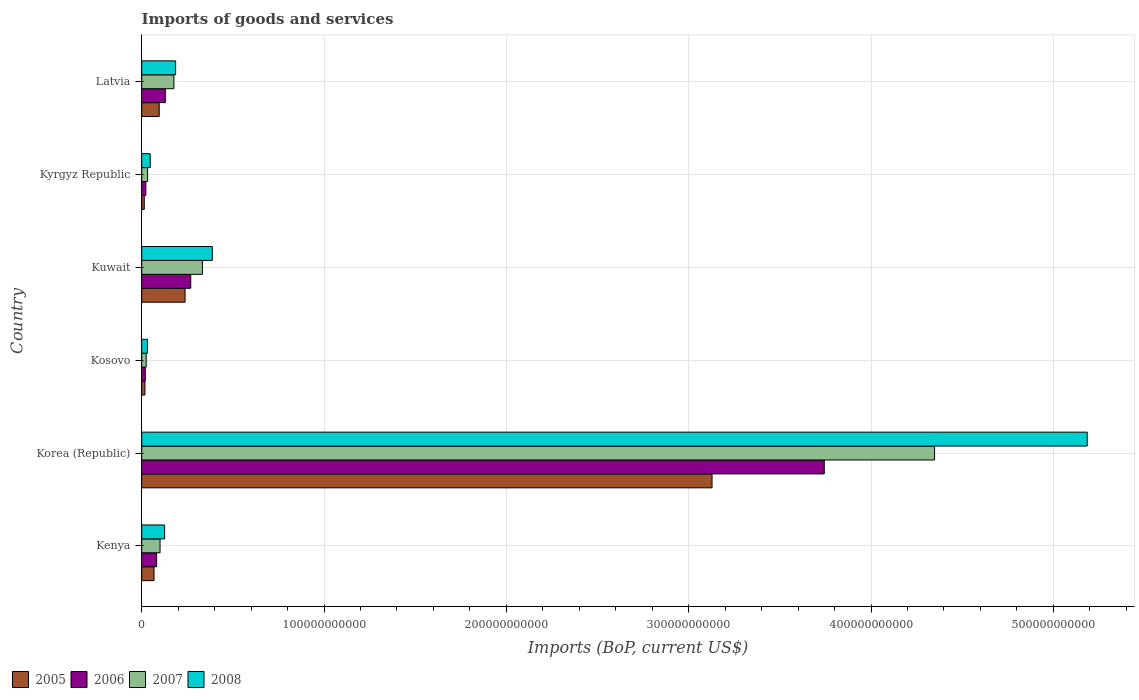Are the number of bars per tick equal to the number of legend labels?
Ensure brevity in your answer.  Yes. Are the number of bars on each tick of the Y-axis equal?
Offer a very short reply. Yes. How many bars are there on the 5th tick from the bottom?
Offer a very short reply. 4. What is the label of the 5th group of bars from the top?
Your answer should be very brief. Korea (Republic). What is the amount spent on imports in 2006 in Korea (Republic)?
Offer a terse response. 3.74e+11. Across all countries, what is the maximum amount spent on imports in 2005?
Keep it short and to the point. 3.13e+11. Across all countries, what is the minimum amount spent on imports in 2006?
Ensure brevity in your answer.  1.95e+09. In which country was the amount spent on imports in 2007 maximum?
Provide a short and direct response. Korea (Republic). In which country was the amount spent on imports in 2008 minimum?
Offer a very short reply. Kosovo. What is the total amount spent on imports in 2008 in the graph?
Give a very brief answer. 5.96e+11. What is the difference between the amount spent on imports in 2007 in Kenya and that in Kosovo?
Ensure brevity in your answer.  7.60e+09. What is the difference between the amount spent on imports in 2005 in Kuwait and the amount spent on imports in 2008 in Latvia?
Keep it short and to the point. 5.17e+09. What is the average amount spent on imports in 2005 per country?
Offer a terse response. 5.93e+1. What is the difference between the amount spent on imports in 2005 and amount spent on imports in 2006 in Latvia?
Give a very brief answer. -3.35e+09. In how many countries, is the amount spent on imports in 2005 greater than 480000000000 US$?
Keep it short and to the point. 0. What is the ratio of the amount spent on imports in 2007 in Kenya to that in Latvia?
Keep it short and to the point. 0.57. Is the amount spent on imports in 2007 in Kenya less than that in Kyrgyz Republic?
Your answer should be very brief. No. What is the difference between the highest and the second highest amount spent on imports in 2008?
Provide a short and direct response. 4.80e+11. What is the difference between the highest and the lowest amount spent on imports in 2007?
Provide a succinct answer. 4.32e+11. Is the sum of the amount spent on imports in 2008 in Kenya and Kyrgyz Republic greater than the maximum amount spent on imports in 2005 across all countries?
Ensure brevity in your answer.  No. Is it the case that in every country, the sum of the amount spent on imports in 2008 and amount spent on imports in 2006 is greater than the sum of amount spent on imports in 2005 and amount spent on imports in 2007?
Make the answer very short. No. What does the 2nd bar from the bottom in Kuwait represents?
Your answer should be compact. 2006. Is it the case that in every country, the sum of the amount spent on imports in 2008 and amount spent on imports in 2006 is greater than the amount spent on imports in 2005?
Keep it short and to the point. Yes. Are all the bars in the graph horizontal?
Make the answer very short. Yes. What is the difference between two consecutive major ticks on the X-axis?
Make the answer very short. 1.00e+11. Are the values on the major ticks of X-axis written in scientific E-notation?
Your answer should be very brief. No. Does the graph contain any zero values?
Make the answer very short. No. Where does the legend appear in the graph?
Provide a succinct answer. Bottom left. How are the legend labels stacked?
Provide a succinct answer. Horizontal. What is the title of the graph?
Your answer should be compact. Imports of goods and services. Does "2001" appear as one of the legend labels in the graph?
Your answer should be very brief. No. What is the label or title of the X-axis?
Provide a succinct answer. Imports (BoP, current US$). What is the Imports (BoP, current US$) of 2005 in Kenya?
Give a very brief answer. 6.74e+09. What is the Imports (BoP, current US$) of 2006 in Kenya?
Make the answer very short. 8.17e+09. What is the Imports (BoP, current US$) in 2007 in Kenya?
Your answer should be very brief. 1.01e+1. What is the Imports (BoP, current US$) in 2008 in Kenya?
Provide a short and direct response. 1.26e+1. What is the Imports (BoP, current US$) of 2005 in Korea (Republic)?
Ensure brevity in your answer.  3.13e+11. What is the Imports (BoP, current US$) in 2006 in Korea (Republic)?
Your answer should be very brief. 3.74e+11. What is the Imports (BoP, current US$) in 2007 in Korea (Republic)?
Your response must be concise. 4.35e+11. What is the Imports (BoP, current US$) of 2008 in Korea (Republic)?
Your answer should be compact. 5.19e+11. What is the Imports (BoP, current US$) of 2005 in Kosovo?
Offer a terse response. 1.76e+09. What is the Imports (BoP, current US$) in 2006 in Kosovo?
Keep it short and to the point. 1.95e+09. What is the Imports (BoP, current US$) in 2007 in Kosovo?
Your answer should be compact. 2.46e+09. What is the Imports (BoP, current US$) in 2008 in Kosovo?
Ensure brevity in your answer.  3.12e+09. What is the Imports (BoP, current US$) of 2005 in Kuwait?
Make the answer very short. 2.38e+1. What is the Imports (BoP, current US$) in 2006 in Kuwait?
Your answer should be very brief. 2.69e+1. What is the Imports (BoP, current US$) in 2007 in Kuwait?
Ensure brevity in your answer.  3.33e+1. What is the Imports (BoP, current US$) in 2008 in Kuwait?
Provide a succinct answer. 3.87e+1. What is the Imports (BoP, current US$) in 2005 in Kyrgyz Republic?
Offer a very short reply. 1.40e+09. What is the Imports (BoP, current US$) of 2006 in Kyrgyz Republic?
Provide a succinct answer. 2.25e+09. What is the Imports (BoP, current US$) in 2007 in Kyrgyz Republic?
Ensure brevity in your answer.  3.22e+09. What is the Imports (BoP, current US$) of 2008 in Kyrgyz Republic?
Your answer should be compact. 4.66e+09. What is the Imports (BoP, current US$) of 2005 in Latvia?
Your answer should be compact. 9.60e+09. What is the Imports (BoP, current US$) in 2006 in Latvia?
Provide a short and direct response. 1.29e+1. What is the Imports (BoP, current US$) of 2007 in Latvia?
Ensure brevity in your answer.  1.76e+1. What is the Imports (BoP, current US$) in 2008 in Latvia?
Keep it short and to the point. 1.86e+1. Across all countries, what is the maximum Imports (BoP, current US$) of 2005?
Your answer should be very brief. 3.13e+11. Across all countries, what is the maximum Imports (BoP, current US$) in 2006?
Make the answer very short. 3.74e+11. Across all countries, what is the maximum Imports (BoP, current US$) in 2007?
Your response must be concise. 4.35e+11. Across all countries, what is the maximum Imports (BoP, current US$) of 2008?
Offer a terse response. 5.19e+11. Across all countries, what is the minimum Imports (BoP, current US$) in 2005?
Make the answer very short. 1.40e+09. Across all countries, what is the minimum Imports (BoP, current US$) of 2006?
Make the answer very short. 1.95e+09. Across all countries, what is the minimum Imports (BoP, current US$) of 2007?
Provide a short and direct response. 2.46e+09. Across all countries, what is the minimum Imports (BoP, current US$) in 2008?
Provide a short and direct response. 3.12e+09. What is the total Imports (BoP, current US$) in 2005 in the graph?
Your answer should be compact. 3.56e+11. What is the total Imports (BoP, current US$) of 2006 in the graph?
Give a very brief answer. 4.27e+11. What is the total Imports (BoP, current US$) of 2007 in the graph?
Give a very brief answer. 5.02e+11. What is the total Imports (BoP, current US$) in 2008 in the graph?
Your answer should be very brief. 5.96e+11. What is the difference between the Imports (BoP, current US$) of 2005 in Kenya and that in Korea (Republic)?
Make the answer very short. -3.06e+11. What is the difference between the Imports (BoP, current US$) in 2006 in Kenya and that in Korea (Republic)?
Keep it short and to the point. -3.66e+11. What is the difference between the Imports (BoP, current US$) in 2007 in Kenya and that in Korea (Republic)?
Keep it short and to the point. -4.25e+11. What is the difference between the Imports (BoP, current US$) of 2008 in Kenya and that in Korea (Republic)?
Your response must be concise. -5.06e+11. What is the difference between the Imports (BoP, current US$) of 2005 in Kenya and that in Kosovo?
Your response must be concise. 4.97e+09. What is the difference between the Imports (BoP, current US$) in 2006 in Kenya and that in Kosovo?
Provide a short and direct response. 6.22e+09. What is the difference between the Imports (BoP, current US$) in 2007 in Kenya and that in Kosovo?
Provide a succinct answer. 7.60e+09. What is the difference between the Imports (BoP, current US$) of 2008 in Kenya and that in Kosovo?
Offer a very short reply. 9.44e+09. What is the difference between the Imports (BoP, current US$) in 2005 in Kenya and that in Kuwait?
Offer a very short reply. -1.70e+1. What is the difference between the Imports (BoP, current US$) of 2006 in Kenya and that in Kuwait?
Keep it short and to the point. -1.87e+1. What is the difference between the Imports (BoP, current US$) in 2007 in Kenya and that in Kuwait?
Ensure brevity in your answer.  -2.32e+1. What is the difference between the Imports (BoP, current US$) of 2008 in Kenya and that in Kuwait?
Offer a terse response. -2.62e+1. What is the difference between the Imports (BoP, current US$) in 2005 in Kenya and that in Kyrgyz Republic?
Your answer should be compact. 5.34e+09. What is the difference between the Imports (BoP, current US$) of 2006 in Kenya and that in Kyrgyz Republic?
Ensure brevity in your answer.  5.92e+09. What is the difference between the Imports (BoP, current US$) of 2007 in Kenya and that in Kyrgyz Republic?
Your response must be concise. 6.84e+09. What is the difference between the Imports (BoP, current US$) of 2008 in Kenya and that in Kyrgyz Republic?
Make the answer very short. 7.90e+09. What is the difference between the Imports (BoP, current US$) in 2005 in Kenya and that in Latvia?
Offer a very short reply. -2.86e+09. What is the difference between the Imports (BoP, current US$) in 2006 in Kenya and that in Latvia?
Make the answer very short. -4.77e+09. What is the difference between the Imports (BoP, current US$) in 2007 in Kenya and that in Latvia?
Provide a short and direct response. -7.59e+09. What is the difference between the Imports (BoP, current US$) in 2008 in Kenya and that in Latvia?
Your response must be concise. -6.03e+09. What is the difference between the Imports (BoP, current US$) in 2005 in Korea (Republic) and that in Kosovo?
Provide a succinct answer. 3.11e+11. What is the difference between the Imports (BoP, current US$) of 2006 in Korea (Republic) and that in Kosovo?
Provide a short and direct response. 3.72e+11. What is the difference between the Imports (BoP, current US$) in 2007 in Korea (Republic) and that in Kosovo?
Give a very brief answer. 4.32e+11. What is the difference between the Imports (BoP, current US$) of 2008 in Korea (Republic) and that in Kosovo?
Your response must be concise. 5.15e+11. What is the difference between the Imports (BoP, current US$) of 2005 in Korea (Republic) and that in Kuwait?
Offer a very short reply. 2.89e+11. What is the difference between the Imports (BoP, current US$) of 2006 in Korea (Republic) and that in Kuwait?
Offer a terse response. 3.47e+11. What is the difference between the Imports (BoP, current US$) in 2007 in Korea (Republic) and that in Kuwait?
Make the answer very short. 4.02e+11. What is the difference between the Imports (BoP, current US$) of 2008 in Korea (Republic) and that in Kuwait?
Keep it short and to the point. 4.80e+11. What is the difference between the Imports (BoP, current US$) of 2005 in Korea (Republic) and that in Kyrgyz Republic?
Offer a terse response. 3.11e+11. What is the difference between the Imports (BoP, current US$) of 2006 in Korea (Republic) and that in Kyrgyz Republic?
Your response must be concise. 3.72e+11. What is the difference between the Imports (BoP, current US$) in 2007 in Korea (Republic) and that in Kyrgyz Republic?
Keep it short and to the point. 4.32e+11. What is the difference between the Imports (BoP, current US$) of 2008 in Korea (Republic) and that in Kyrgyz Republic?
Your answer should be very brief. 5.14e+11. What is the difference between the Imports (BoP, current US$) in 2005 in Korea (Republic) and that in Latvia?
Your response must be concise. 3.03e+11. What is the difference between the Imports (BoP, current US$) of 2006 in Korea (Republic) and that in Latvia?
Ensure brevity in your answer.  3.61e+11. What is the difference between the Imports (BoP, current US$) in 2007 in Korea (Republic) and that in Latvia?
Your answer should be compact. 4.17e+11. What is the difference between the Imports (BoP, current US$) of 2008 in Korea (Republic) and that in Latvia?
Your answer should be compact. 5.00e+11. What is the difference between the Imports (BoP, current US$) in 2005 in Kosovo and that in Kuwait?
Your response must be concise. -2.20e+1. What is the difference between the Imports (BoP, current US$) in 2006 in Kosovo and that in Kuwait?
Offer a very short reply. -2.49e+1. What is the difference between the Imports (BoP, current US$) of 2007 in Kosovo and that in Kuwait?
Ensure brevity in your answer.  -3.08e+1. What is the difference between the Imports (BoP, current US$) of 2008 in Kosovo and that in Kuwait?
Offer a very short reply. -3.56e+1. What is the difference between the Imports (BoP, current US$) in 2005 in Kosovo and that in Kyrgyz Republic?
Provide a succinct answer. 3.69e+08. What is the difference between the Imports (BoP, current US$) of 2006 in Kosovo and that in Kyrgyz Republic?
Your answer should be very brief. -3.02e+08. What is the difference between the Imports (BoP, current US$) in 2007 in Kosovo and that in Kyrgyz Republic?
Offer a terse response. -7.58e+08. What is the difference between the Imports (BoP, current US$) in 2008 in Kosovo and that in Kyrgyz Republic?
Ensure brevity in your answer.  -1.54e+09. What is the difference between the Imports (BoP, current US$) of 2005 in Kosovo and that in Latvia?
Provide a short and direct response. -7.83e+09. What is the difference between the Imports (BoP, current US$) in 2006 in Kosovo and that in Latvia?
Provide a succinct answer. -1.10e+1. What is the difference between the Imports (BoP, current US$) of 2007 in Kosovo and that in Latvia?
Offer a very short reply. -1.52e+1. What is the difference between the Imports (BoP, current US$) of 2008 in Kosovo and that in Latvia?
Provide a short and direct response. -1.55e+1. What is the difference between the Imports (BoP, current US$) in 2005 in Kuwait and that in Kyrgyz Republic?
Offer a very short reply. 2.24e+1. What is the difference between the Imports (BoP, current US$) in 2006 in Kuwait and that in Kyrgyz Republic?
Your response must be concise. 2.46e+1. What is the difference between the Imports (BoP, current US$) in 2007 in Kuwait and that in Kyrgyz Republic?
Make the answer very short. 3.01e+1. What is the difference between the Imports (BoP, current US$) in 2008 in Kuwait and that in Kyrgyz Republic?
Your answer should be compact. 3.41e+1. What is the difference between the Imports (BoP, current US$) of 2005 in Kuwait and that in Latvia?
Provide a short and direct response. 1.42e+1. What is the difference between the Imports (BoP, current US$) of 2006 in Kuwait and that in Latvia?
Keep it short and to the point. 1.39e+1. What is the difference between the Imports (BoP, current US$) of 2007 in Kuwait and that in Latvia?
Give a very brief answer. 1.57e+1. What is the difference between the Imports (BoP, current US$) of 2008 in Kuwait and that in Latvia?
Your response must be concise. 2.01e+1. What is the difference between the Imports (BoP, current US$) in 2005 in Kyrgyz Republic and that in Latvia?
Your answer should be compact. -8.20e+09. What is the difference between the Imports (BoP, current US$) in 2006 in Kyrgyz Republic and that in Latvia?
Ensure brevity in your answer.  -1.07e+1. What is the difference between the Imports (BoP, current US$) of 2007 in Kyrgyz Republic and that in Latvia?
Provide a short and direct response. -1.44e+1. What is the difference between the Imports (BoP, current US$) in 2008 in Kyrgyz Republic and that in Latvia?
Provide a succinct answer. -1.39e+1. What is the difference between the Imports (BoP, current US$) in 2005 in Kenya and the Imports (BoP, current US$) in 2006 in Korea (Republic)?
Give a very brief answer. -3.68e+11. What is the difference between the Imports (BoP, current US$) in 2005 in Kenya and the Imports (BoP, current US$) in 2007 in Korea (Republic)?
Make the answer very short. -4.28e+11. What is the difference between the Imports (BoP, current US$) in 2005 in Kenya and the Imports (BoP, current US$) in 2008 in Korea (Republic)?
Ensure brevity in your answer.  -5.12e+11. What is the difference between the Imports (BoP, current US$) in 2006 in Kenya and the Imports (BoP, current US$) in 2007 in Korea (Republic)?
Your answer should be compact. -4.27e+11. What is the difference between the Imports (BoP, current US$) in 2006 in Kenya and the Imports (BoP, current US$) in 2008 in Korea (Republic)?
Keep it short and to the point. -5.10e+11. What is the difference between the Imports (BoP, current US$) in 2007 in Kenya and the Imports (BoP, current US$) in 2008 in Korea (Republic)?
Your answer should be very brief. -5.09e+11. What is the difference between the Imports (BoP, current US$) of 2005 in Kenya and the Imports (BoP, current US$) of 2006 in Kosovo?
Ensure brevity in your answer.  4.79e+09. What is the difference between the Imports (BoP, current US$) in 2005 in Kenya and the Imports (BoP, current US$) in 2007 in Kosovo?
Provide a succinct answer. 4.28e+09. What is the difference between the Imports (BoP, current US$) of 2005 in Kenya and the Imports (BoP, current US$) of 2008 in Kosovo?
Your response must be concise. 3.62e+09. What is the difference between the Imports (BoP, current US$) in 2006 in Kenya and the Imports (BoP, current US$) in 2007 in Kosovo?
Make the answer very short. 5.71e+09. What is the difference between the Imports (BoP, current US$) of 2006 in Kenya and the Imports (BoP, current US$) of 2008 in Kosovo?
Keep it short and to the point. 5.05e+09. What is the difference between the Imports (BoP, current US$) in 2007 in Kenya and the Imports (BoP, current US$) in 2008 in Kosovo?
Provide a succinct answer. 6.94e+09. What is the difference between the Imports (BoP, current US$) of 2005 in Kenya and the Imports (BoP, current US$) of 2006 in Kuwait?
Your answer should be very brief. -2.01e+1. What is the difference between the Imports (BoP, current US$) of 2005 in Kenya and the Imports (BoP, current US$) of 2007 in Kuwait?
Offer a terse response. -2.66e+1. What is the difference between the Imports (BoP, current US$) in 2005 in Kenya and the Imports (BoP, current US$) in 2008 in Kuwait?
Keep it short and to the point. -3.20e+1. What is the difference between the Imports (BoP, current US$) in 2006 in Kenya and the Imports (BoP, current US$) in 2007 in Kuwait?
Give a very brief answer. -2.51e+1. What is the difference between the Imports (BoP, current US$) of 2006 in Kenya and the Imports (BoP, current US$) of 2008 in Kuwait?
Provide a short and direct response. -3.05e+1. What is the difference between the Imports (BoP, current US$) of 2007 in Kenya and the Imports (BoP, current US$) of 2008 in Kuwait?
Offer a terse response. -2.87e+1. What is the difference between the Imports (BoP, current US$) in 2005 in Kenya and the Imports (BoP, current US$) in 2006 in Kyrgyz Republic?
Ensure brevity in your answer.  4.49e+09. What is the difference between the Imports (BoP, current US$) of 2005 in Kenya and the Imports (BoP, current US$) of 2007 in Kyrgyz Republic?
Provide a short and direct response. 3.52e+09. What is the difference between the Imports (BoP, current US$) of 2005 in Kenya and the Imports (BoP, current US$) of 2008 in Kyrgyz Republic?
Your answer should be very brief. 2.08e+09. What is the difference between the Imports (BoP, current US$) in 2006 in Kenya and the Imports (BoP, current US$) in 2007 in Kyrgyz Republic?
Make the answer very short. 4.95e+09. What is the difference between the Imports (BoP, current US$) in 2006 in Kenya and the Imports (BoP, current US$) in 2008 in Kyrgyz Republic?
Your answer should be very brief. 3.51e+09. What is the difference between the Imports (BoP, current US$) of 2007 in Kenya and the Imports (BoP, current US$) of 2008 in Kyrgyz Republic?
Ensure brevity in your answer.  5.40e+09. What is the difference between the Imports (BoP, current US$) in 2005 in Kenya and the Imports (BoP, current US$) in 2006 in Latvia?
Your answer should be very brief. -6.21e+09. What is the difference between the Imports (BoP, current US$) in 2005 in Kenya and the Imports (BoP, current US$) in 2007 in Latvia?
Offer a very short reply. -1.09e+1. What is the difference between the Imports (BoP, current US$) of 2005 in Kenya and the Imports (BoP, current US$) of 2008 in Latvia?
Give a very brief answer. -1.19e+1. What is the difference between the Imports (BoP, current US$) in 2006 in Kenya and the Imports (BoP, current US$) in 2007 in Latvia?
Provide a succinct answer. -9.48e+09. What is the difference between the Imports (BoP, current US$) in 2006 in Kenya and the Imports (BoP, current US$) in 2008 in Latvia?
Offer a very short reply. -1.04e+1. What is the difference between the Imports (BoP, current US$) of 2007 in Kenya and the Imports (BoP, current US$) of 2008 in Latvia?
Your answer should be compact. -8.54e+09. What is the difference between the Imports (BoP, current US$) in 2005 in Korea (Republic) and the Imports (BoP, current US$) in 2006 in Kosovo?
Give a very brief answer. 3.11e+11. What is the difference between the Imports (BoP, current US$) of 2005 in Korea (Republic) and the Imports (BoP, current US$) of 2007 in Kosovo?
Give a very brief answer. 3.10e+11. What is the difference between the Imports (BoP, current US$) of 2005 in Korea (Republic) and the Imports (BoP, current US$) of 2008 in Kosovo?
Ensure brevity in your answer.  3.10e+11. What is the difference between the Imports (BoP, current US$) of 2006 in Korea (Republic) and the Imports (BoP, current US$) of 2007 in Kosovo?
Offer a terse response. 3.72e+11. What is the difference between the Imports (BoP, current US$) in 2006 in Korea (Republic) and the Imports (BoP, current US$) in 2008 in Kosovo?
Provide a short and direct response. 3.71e+11. What is the difference between the Imports (BoP, current US$) in 2007 in Korea (Republic) and the Imports (BoP, current US$) in 2008 in Kosovo?
Your answer should be very brief. 4.32e+11. What is the difference between the Imports (BoP, current US$) of 2005 in Korea (Republic) and the Imports (BoP, current US$) of 2006 in Kuwait?
Ensure brevity in your answer.  2.86e+11. What is the difference between the Imports (BoP, current US$) in 2005 in Korea (Republic) and the Imports (BoP, current US$) in 2007 in Kuwait?
Your response must be concise. 2.79e+11. What is the difference between the Imports (BoP, current US$) in 2005 in Korea (Republic) and the Imports (BoP, current US$) in 2008 in Kuwait?
Provide a succinct answer. 2.74e+11. What is the difference between the Imports (BoP, current US$) in 2006 in Korea (Republic) and the Imports (BoP, current US$) in 2007 in Kuwait?
Ensure brevity in your answer.  3.41e+11. What is the difference between the Imports (BoP, current US$) in 2006 in Korea (Republic) and the Imports (BoP, current US$) in 2008 in Kuwait?
Offer a terse response. 3.36e+11. What is the difference between the Imports (BoP, current US$) of 2007 in Korea (Republic) and the Imports (BoP, current US$) of 2008 in Kuwait?
Give a very brief answer. 3.96e+11. What is the difference between the Imports (BoP, current US$) in 2005 in Korea (Republic) and the Imports (BoP, current US$) in 2006 in Kyrgyz Republic?
Offer a terse response. 3.11e+11. What is the difference between the Imports (BoP, current US$) of 2005 in Korea (Republic) and the Imports (BoP, current US$) of 2007 in Kyrgyz Republic?
Keep it short and to the point. 3.10e+11. What is the difference between the Imports (BoP, current US$) in 2005 in Korea (Republic) and the Imports (BoP, current US$) in 2008 in Kyrgyz Republic?
Ensure brevity in your answer.  3.08e+11. What is the difference between the Imports (BoP, current US$) of 2006 in Korea (Republic) and the Imports (BoP, current US$) of 2007 in Kyrgyz Republic?
Your answer should be very brief. 3.71e+11. What is the difference between the Imports (BoP, current US$) in 2006 in Korea (Republic) and the Imports (BoP, current US$) in 2008 in Kyrgyz Republic?
Give a very brief answer. 3.70e+11. What is the difference between the Imports (BoP, current US$) in 2007 in Korea (Republic) and the Imports (BoP, current US$) in 2008 in Kyrgyz Republic?
Your answer should be very brief. 4.30e+11. What is the difference between the Imports (BoP, current US$) of 2005 in Korea (Republic) and the Imports (BoP, current US$) of 2006 in Latvia?
Offer a terse response. 3.00e+11. What is the difference between the Imports (BoP, current US$) in 2005 in Korea (Republic) and the Imports (BoP, current US$) in 2007 in Latvia?
Keep it short and to the point. 2.95e+11. What is the difference between the Imports (BoP, current US$) of 2005 in Korea (Republic) and the Imports (BoP, current US$) of 2008 in Latvia?
Make the answer very short. 2.94e+11. What is the difference between the Imports (BoP, current US$) in 2006 in Korea (Republic) and the Imports (BoP, current US$) in 2007 in Latvia?
Your answer should be very brief. 3.57e+11. What is the difference between the Imports (BoP, current US$) in 2006 in Korea (Republic) and the Imports (BoP, current US$) in 2008 in Latvia?
Ensure brevity in your answer.  3.56e+11. What is the difference between the Imports (BoP, current US$) in 2007 in Korea (Republic) and the Imports (BoP, current US$) in 2008 in Latvia?
Make the answer very short. 4.16e+11. What is the difference between the Imports (BoP, current US$) of 2005 in Kosovo and the Imports (BoP, current US$) of 2006 in Kuwait?
Ensure brevity in your answer.  -2.51e+1. What is the difference between the Imports (BoP, current US$) of 2005 in Kosovo and the Imports (BoP, current US$) of 2007 in Kuwait?
Ensure brevity in your answer.  -3.15e+1. What is the difference between the Imports (BoP, current US$) of 2005 in Kosovo and the Imports (BoP, current US$) of 2008 in Kuwait?
Give a very brief answer. -3.70e+1. What is the difference between the Imports (BoP, current US$) in 2006 in Kosovo and the Imports (BoP, current US$) in 2007 in Kuwait?
Ensure brevity in your answer.  -3.14e+1. What is the difference between the Imports (BoP, current US$) of 2006 in Kosovo and the Imports (BoP, current US$) of 2008 in Kuwait?
Your answer should be very brief. -3.68e+1. What is the difference between the Imports (BoP, current US$) in 2007 in Kosovo and the Imports (BoP, current US$) in 2008 in Kuwait?
Provide a short and direct response. -3.63e+1. What is the difference between the Imports (BoP, current US$) of 2005 in Kosovo and the Imports (BoP, current US$) of 2006 in Kyrgyz Republic?
Keep it short and to the point. -4.88e+08. What is the difference between the Imports (BoP, current US$) of 2005 in Kosovo and the Imports (BoP, current US$) of 2007 in Kyrgyz Republic?
Ensure brevity in your answer.  -1.45e+09. What is the difference between the Imports (BoP, current US$) in 2005 in Kosovo and the Imports (BoP, current US$) in 2008 in Kyrgyz Republic?
Your answer should be compact. -2.90e+09. What is the difference between the Imports (BoP, current US$) in 2006 in Kosovo and the Imports (BoP, current US$) in 2007 in Kyrgyz Republic?
Your response must be concise. -1.27e+09. What is the difference between the Imports (BoP, current US$) in 2006 in Kosovo and the Imports (BoP, current US$) in 2008 in Kyrgyz Republic?
Give a very brief answer. -2.71e+09. What is the difference between the Imports (BoP, current US$) of 2007 in Kosovo and the Imports (BoP, current US$) of 2008 in Kyrgyz Republic?
Your answer should be compact. -2.20e+09. What is the difference between the Imports (BoP, current US$) in 2005 in Kosovo and the Imports (BoP, current US$) in 2006 in Latvia?
Your answer should be very brief. -1.12e+1. What is the difference between the Imports (BoP, current US$) of 2005 in Kosovo and the Imports (BoP, current US$) of 2007 in Latvia?
Offer a terse response. -1.59e+1. What is the difference between the Imports (BoP, current US$) of 2005 in Kosovo and the Imports (BoP, current US$) of 2008 in Latvia?
Ensure brevity in your answer.  -1.68e+1. What is the difference between the Imports (BoP, current US$) in 2006 in Kosovo and the Imports (BoP, current US$) in 2007 in Latvia?
Your answer should be very brief. -1.57e+1. What is the difference between the Imports (BoP, current US$) in 2006 in Kosovo and the Imports (BoP, current US$) in 2008 in Latvia?
Provide a short and direct response. -1.66e+1. What is the difference between the Imports (BoP, current US$) in 2007 in Kosovo and the Imports (BoP, current US$) in 2008 in Latvia?
Offer a very short reply. -1.61e+1. What is the difference between the Imports (BoP, current US$) in 2005 in Kuwait and the Imports (BoP, current US$) in 2006 in Kyrgyz Republic?
Provide a succinct answer. 2.15e+1. What is the difference between the Imports (BoP, current US$) in 2005 in Kuwait and the Imports (BoP, current US$) in 2007 in Kyrgyz Republic?
Provide a short and direct response. 2.06e+1. What is the difference between the Imports (BoP, current US$) of 2005 in Kuwait and the Imports (BoP, current US$) of 2008 in Kyrgyz Republic?
Your response must be concise. 1.91e+1. What is the difference between the Imports (BoP, current US$) in 2006 in Kuwait and the Imports (BoP, current US$) in 2007 in Kyrgyz Republic?
Your response must be concise. 2.37e+1. What is the difference between the Imports (BoP, current US$) in 2006 in Kuwait and the Imports (BoP, current US$) in 2008 in Kyrgyz Republic?
Offer a very short reply. 2.22e+1. What is the difference between the Imports (BoP, current US$) in 2007 in Kuwait and the Imports (BoP, current US$) in 2008 in Kyrgyz Republic?
Ensure brevity in your answer.  2.86e+1. What is the difference between the Imports (BoP, current US$) of 2005 in Kuwait and the Imports (BoP, current US$) of 2006 in Latvia?
Offer a terse response. 1.08e+1. What is the difference between the Imports (BoP, current US$) of 2005 in Kuwait and the Imports (BoP, current US$) of 2007 in Latvia?
Give a very brief answer. 6.12e+09. What is the difference between the Imports (BoP, current US$) in 2005 in Kuwait and the Imports (BoP, current US$) in 2008 in Latvia?
Ensure brevity in your answer.  5.17e+09. What is the difference between the Imports (BoP, current US$) of 2006 in Kuwait and the Imports (BoP, current US$) of 2007 in Latvia?
Keep it short and to the point. 9.23e+09. What is the difference between the Imports (BoP, current US$) of 2006 in Kuwait and the Imports (BoP, current US$) of 2008 in Latvia?
Your answer should be very brief. 8.28e+09. What is the difference between the Imports (BoP, current US$) in 2007 in Kuwait and the Imports (BoP, current US$) in 2008 in Latvia?
Your response must be concise. 1.47e+1. What is the difference between the Imports (BoP, current US$) in 2005 in Kyrgyz Republic and the Imports (BoP, current US$) in 2006 in Latvia?
Make the answer very short. -1.15e+1. What is the difference between the Imports (BoP, current US$) in 2005 in Kyrgyz Republic and the Imports (BoP, current US$) in 2007 in Latvia?
Give a very brief answer. -1.63e+1. What is the difference between the Imports (BoP, current US$) in 2005 in Kyrgyz Republic and the Imports (BoP, current US$) in 2008 in Latvia?
Give a very brief answer. -1.72e+1. What is the difference between the Imports (BoP, current US$) of 2006 in Kyrgyz Republic and the Imports (BoP, current US$) of 2007 in Latvia?
Keep it short and to the point. -1.54e+1. What is the difference between the Imports (BoP, current US$) of 2006 in Kyrgyz Republic and the Imports (BoP, current US$) of 2008 in Latvia?
Give a very brief answer. -1.63e+1. What is the difference between the Imports (BoP, current US$) of 2007 in Kyrgyz Republic and the Imports (BoP, current US$) of 2008 in Latvia?
Provide a succinct answer. -1.54e+1. What is the average Imports (BoP, current US$) of 2005 per country?
Ensure brevity in your answer.  5.93e+1. What is the average Imports (BoP, current US$) of 2006 per country?
Provide a succinct answer. 7.11e+1. What is the average Imports (BoP, current US$) in 2007 per country?
Make the answer very short. 8.36e+1. What is the average Imports (BoP, current US$) in 2008 per country?
Offer a terse response. 9.94e+1. What is the difference between the Imports (BoP, current US$) of 2005 and Imports (BoP, current US$) of 2006 in Kenya?
Give a very brief answer. -1.43e+09. What is the difference between the Imports (BoP, current US$) in 2005 and Imports (BoP, current US$) in 2007 in Kenya?
Offer a very short reply. -3.32e+09. What is the difference between the Imports (BoP, current US$) of 2005 and Imports (BoP, current US$) of 2008 in Kenya?
Make the answer very short. -5.82e+09. What is the difference between the Imports (BoP, current US$) in 2006 and Imports (BoP, current US$) in 2007 in Kenya?
Your answer should be very brief. -1.89e+09. What is the difference between the Imports (BoP, current US$) of 2006 and Imports (BoP, current US$) of 2008 in Kenya?
Keep it short and to the point. -4.39e+09. What is the difference between the Imports (BoP, current US$) of 2007 and Imports (BoP, current US$) of 2008 in Kenya?
Provide a short and direct response. -2.50e+09. What is the difference between the Imports (BoP, current US$) in 2005 and Imports (BoP, current US$) in 2006 in Korea (Republic)?
Make the answer very short. -6.16e+1. What is the difference between the Imports (BoP, current US$) of 2005 and Imports (BoP, current US$) of 2007 in Korea (Republic)?
Give a very brief answer. -1.22e+11. What is the difference between the Imports (BoP, current US$) in 2005 and Imports (BoP, current US$) in 2008 in Korea (Republic)?
Your response must be concise. -2.06e+11. What is the difference between the Imports (BoP, current US$) in 2006 and Imports (BoP, current US$) in 2007 in Korea (Republic)?
Your answer should be compact. -6.05e+1. What is the difference between the Imports (BoP, current US$) of 2006 and Imports (BoP, current US$) of 2008 in Korea (Republic)?
Offer a very short reply. -1.44e+11. What is the difference between the Imports (BoP, current US$) of 2007 and Imports (BoP, current US$) of 2008 in Korea (Republic)?
Offer a terse response. -8.37e+1. What is the difference between the Imports (BoP, current US$) in 2005 and Imports (BoP, current US$) in 2006 in Kosovo?
Give a very brief answer. -1.86e+08. What is the difference between the Imports (BoP, current US$) of 2005 and Imports (BoP, current US$) of 2007 in Kosovo?
Your response must be concise. -6.96e+08. What is the difference between the Imports (BoP, current US$) of 2005 and Imports (BoP, current US$) of 2008 in Kosovo?
Give a very brief answer. -1.36e+09. What is the difference between the Imports (BoP, current US$) in 2006 and Imports (BoP, current US$) in 2007 in Kosovo?
Give a very brief answer. -5.10e+08. What is the difference between the Imports (BoP, current US$) in 2006 and Imports (BoP, current US$) in 2008 in Kosovo?
Your answer should be very brief. -1.17e+09. What is the difference between the Imports (BoP, current US$) of 2007 and Imports (BoP, current US$) of 2008 in Kosovo?
Make the answer very short. -6.61e+08. What is the difference between the Imports (BoP, current US$) in 2005 and Imports (BoP, current US$) in 2006 in Kuwait?
Your response must be concise. -3.11e+09. What is the difference between the Imports (BoP, current US$) of 2005 and Imports (BoP, current US$) of 2007 in Kuwait?
Your response must be concise. -9.54e+09. What is the difference between the Imports (BoP, current US$) of 2005 and Imports (BoP, current US$) of 2008 in Kuwait?
Keep it short and to the point. -1.49e+1. What is the difference between the Imports (BoP, current US$) in 2006 and Imports (BoP, current US$) in 2007 in Kuwait?
Keep it short and to the point. -6.43e+09. What is the difference between the Imports (BoP, current US$) of 2006 and Imports (BoP, current US$) of 2008 in Kuwait?
Ensure brevity in your answer.  -1.18e+1. What is the difference between the Imports (BoP, current US$) of 2007 and Imports (BoP, current US$) of 2008 in Kuwait?
Make the answer very short. -5.41e+09. What is the difference between the Imports (BoP, current US$) in 2005 and Imports (BoP, current US$) in 2006 in Kyrgyz Republic?
Ensure brevity in your answer.  -8.56e+08. What is the difference between the Imports (BoP, current US$) of 2005 and Imports (BoP, current US$) of 2007 in Kyrgyz Republic?
Offer a very short reply. -1.82e+09. What is the difference between the Imports (BoP, current US$) of 2005 and Imports (BoP, current US$) of 2008 in Kyrgyz Republic?
Offer a very short reply. -3.27e+09. What is the difference between the Imports (BoP, current US$) of 2006 and Imports (BoP, current US$) of 2007 in Kyrgyz Republic?
Provide a short and direct response. -9.66e+08. What is the difference between the Imports (BoP, current US$) of 2006 and Imports (BoP, current US$) of 2008 in Kyrgyz Republic?
Offer a terse response. -2.41e+09. What is the difference between the Imports (BoP, current US$) in 2007 and Imports (BoP, current US$) in 2008 in Kyrgyz Republic?
Offer a terse response. -1.45e+09. What is the difference between the Imports (BoP, current US$) in 2005 and Imports (BoP, current US$) in 2006 in Latvia?
Offer a very short reply. -3.35e+09. What is the difference between the Imports (BoP, current US$) of 2005 and Imports (BoP, current US$) of 2007 in Latvia?
Ensure brevity in your answer.  -8.05e+09. What is the difference between the Imports (BoP, current US$) in 2005 and Imports (BoP, current US$) in 2008 in Latvia?
Your answer should be very brief. -9.00e+09. What is the difference between the Imports (BoP, current US$) in 2006 and Imports (BoP, current US$) in 2007 in Latvia?
Ensure brevity in your answer.  -4.71e+09. What is the difference between the Imports (BoP, current US$) in 2006 and Imports (BoP, current US$) in 2008 in Latvia?
Offer a terse response. -5.65e+09. What is the difference between the Imports (BoP, current US$) in 2007 and Imports (BoP, current US$) in 2008 in Latvia?
Offer a very short reply. -9.45e+08. What is the ratio of the Imports (BoP, current US$) in 2005 in Kenya to that in Korea (Republic)?
Your answer should be very brief. 0.02. What is the ratio of the Imports (BoP, current US$) of 2006 in Kenya to that in Korea (Republic)?
Provide a short and direct response. 0.02. What is the ratio of the Imports (BoP, current US$) in 2007 in Kenya to that in Korea (Republic)?
Your answer should be very brief. 0.02. What is the ratio of the Imports (BoP, current US$) in 2008 in Kenya to that in Korea (Republic)?
Provide a short and direct response. 0.02. What is the ratio of the Imports (BoP, current US$) in 2005 in Kenya to that in Kosovo?
Make the answer very short. 3.82. What is the ratio of the Imports (BoP, current US$) of 2006 in Kenya to that in Kosovo?
Your answer should be very brief. 4.19. What is the ratio of the Imports (BoP, current US$) of 2007 in Kenya to that in Kosovo?
Keep it short and to the point. 4.09. What is the ratio of the Imports (BoP, current US$) of 2008 in Kenya to that in Kosovo?
Keep it short and to the point. 4.02. What is the ratio of the Imports (BoP, current US$) of 2005 in Kenya to that in Kuwait?
Provide a succinct answer. 0.28. What is the ratio of the Imports (BoP, current US$) of 2006 in Kenya to that in Kuwait?
Your response must be concise. 0.3. What is the ratio of the Imports (BoP, current US$) in 2007 in Kenya to that in Kuwait?
Provide a succinct answer. 0.3. What is the ratio of the Imports (BoP, current US$) in 2008 in Kenya to that in Kuwait?
Make the answer very short. 0.32. What is the ratio of the Imports (BoP, current US$) of 2005 in Kenya to that in Kyrgyz Republic?
Provide a short and direct response. 4.83. What is the ratio of the Imports (BoP, current US$) in 2006 in Kenya to that in Kyrgyz Republic?
Provide a succinct answer. 3.63. What is the ratio of the Imports (BoP, current US$) in 2007 in Kenya to that in Kyrgyz Republic?
Your answer should be compact. 3.13. What is the ratio of the Imports (BoP, current US$) in 2008 in Kenya to that in Kyrgyz Republic?
Offer a terse response. 2.69. What is the ratio of the Imports (BoP, current US$) in 2005 in Kenya to that in Latvia?
Keep it short and to the point. 0.7. What is the ratio of the Imports (BoP, current US$) of 2006 in Kenya to that in Latvia?
Offer a very short reply. 0.63. What is the ratio of the Imports (BoP, current US$) of 2007 in Kenya to that in Latvia?
Offer a terse response. 0.57. What is the ratio of the Imports (BoP, current US$) of 2008 in Kenya to that in Latvia?
Ensure brevity in your answer.  0.68. What is the ratio of the Imports (BoP, current US$) in 2005 in Korea (Republic) to that in Kosovo?
Keep it short and to the point. 177.28. What is the ratio of the Imports (BoP, current US$) in 2006 in Korea (Republic) to that in Kosovo?
Your response must be concise. 191.97. What is the ratio of the Imports (BoP, current US$) in 2007 in Korea (Republic) to that in Kosovo?
Ensure brevity in your answer.  176.75. What is the ratio of the Imports (BoP, current US$) in 2008 in Korea (Republic) to that in Kosovo?
Ensure brevity in your answer.  166.17. What is the ratio of the Imports (BoP, current US$) in 2005 in Korea (Republic) to that in Kuwait?
Ensure brevity in your answer.  13.16. What is the ratio of the Imports (BoP, current US$) of 2006 in Korea (Republic) to that in Kuwait?
Make the answer very short. 13.93. What is the ratio of the Imports (BoP, current US$) of 2007 in Korea (Republic) to that in Kuwait?
Give a very brief answer. 13.06. What is the ratio of the Imports (BoP, current US$) in 2008 in Korea (Republic) to that in Kuwait?
Offer a terse response. 13.39. What is the ratio of the Imports (BoP, current US$) of 2005 in Korea (Republic) to that in Kyrgyz Republic?
Ensure brevity in your answer.  224.1. What is the ratio of the Imports (BoP, current US$) of 2006 in Korea (Republic) to that in Kyrgyz Republic?
Your response must be concise. 166.22. What is the ratio of the Imports (BoP, current US$) of 2007 in Korea (Republic) to that in Kyrgyz Republic?
Make the answer very short. 135.13. What is the ratio of the Imports (BoP, current US$) in 2008 in Korea (Republic) to that in Kyrgyz Republic?
Provide a short and direct response. 111.2. What is the ratio of the Imports (BoP, current US$) in 2005 in Korea (Republic) to that in Latvia?
Offer a very short reply. 32.59. What is the ratio of the Imports (BoP, current US$) in 2006 in Korea (Republic) to that in Latvia?
Your answer should be very brief. 28.92. What is the ratio of the Imports (BoP, current US$) of 2007 in Korea (Republic) to that in Latvia?
Offer a terse response. 24.64. What is the ratio of the Imports (BoP, current US$) in 2008 in Korea (Republic) to that in Latvia?
Offer a very short reply. 27.89. What is the ratio of the Imports (BoP, current US$) in 2005 in Kosovo to that in Kuwait?
Give a very brief answer. 0.07. What is the ratio of the Imports (BoP, current US$) in 2006 in Kosovo to that in Kuwait?
Offer a terse response. 0.07. What is the ratio of the Imports (BoP, current US$) of 2007 in Kosovo to that in Kuwait?
Provide a succinct answer. 0.07. What is the ratio of the Imports (BoP, current US$) of 2008 in Kosovo to that in Kuwait?
Your answer should be compact. 0.08. What is the ratio of the Imports (BoP, current US$) of 2005 in Kosovo to that in Kyrgyz Republic?
Ensure brevity in your answer.  1.26. What is the ratio of the Imports (BoP, current US$) of 2006 in Kosovo to that in Kyrgyz Republic?
Keep it short and to the point. 0.87. What is the ratio of the Imports (BoP, current US$) in 2007 in Kosovo to that in Kyrgyz Republic?
Your answer should be compact. 0.76. What is the ratio of the Imports (BoP, current US$) in 2008 in Kosovo to that in Kyrgyz Republic?
Provide a succinct answer. 0.67. What is the ratio of the Imports (BoP, current US$) of 2005 in Kosovo to that in Latvia?
Offer a very short reply. 0.18. What is the ratio of the Imports (BoP, current US$) in 2006 in Kosovo to that in Latvia?
Provide a short and direct response. 0.15. What is the ratio of the Imports (BoP, current US$) of 2007 in Kosovo to that in Latvia?
Keep it short and to the point. 0.14. What is the ratio of the Imports (BoP, current US$) in 2008 in Kosovo to that in Latvia?
Your answer should be compact. 0.17. What is the ratio of the Imports (BoP, current US$) in 2005 in Kuwait to that in Kyrgyz Republic?
Offer a very short reply. 17.03. What is the ratio of the Imports (BoP, current US$) in 2006 in Kuwait to that in Kyrgyz Republic?
Make the answer very short. 11.93. What is the ratio of the Imports (BoP, current US$) in 2007 in Kuwait to that in Kyrgyz Republic?
Offer a terse response. 10.35. What is the ratio of the Imports (BoP, current US$) in 2008 in Kuwait to that in Kyrgyz Republic?
Your answer should be very brief. 8.3. What is the ratio of the Imports (BoP, current US$) of 2005 in Kuwait to that in Latvia?
Make the answer very short. 2.48. What is the ratio of the Imports (BoP, current US$) in 2006 in Kuwait to that in Latvia?
Give a very brief answer. 2.08. What is the ratio of the Imports (BoP, current US$) of 2007 in Kuwait to that in Latvia?
Make the answer very short. 1.89. What is the ratio of the Imports (BoP, current US$) of 2008 in Kuwait to that in Latvia?
Give a very brief answer. 2.08. What is the ratio of the Imports (BoP, current US$) of 2005 in Kyrgyz Republic to that in Latvia?
Make the answer very short. 0.15. What is the ratio of the Imports (BoP, current US$) in 2006 in Kyrgyz Republic to that in Latvia?
Your answer should be very brief. 0.17. What is the ratio of the Imports (BoP, current US$) of 2007 in Kyrgyz Republic to that in Latvia?
Offer a terse response. 0.18. What is the ratio of the Imports (BoP, current US$) in 2008 in Kyrgyz Republic to that in Latvia?
Ensure brevity in your answer.  0.25. What is the difference between the highest and the second highest Imports (BoP, current US$) in 2005?
Your answer should be compact. 2.89e+11. What is the difference between the highest and the second highest Imports (BoP, current US$) in 2006?
Ensure brevity in your answer.  3.47e+11. What is the difference between the highest and the second highest Imports (BoP, current US$) in 2007?
Your answer should be compact. 4.02e+11. What is the difference between the highest and the second highest Imports (BoP, current US$) in 2008?
Ensure brevity in your answer.  4.80e+11. What is the difference between the highest and the lowest Imports (BoP, current US$) of 2005?
Offer a terse response. 3.11e+11. What is the difference between the highest and the lowest Imports (BoP, current US$) of 2006?
Keep it short and to the point. 3.72e+11. What is the difference between the highest and the lowest Imports (BoP, current US$) of 2007?
Provide a succinct answer. 4.32e+11. What is the difference between the highest and the lowest Imports (BoP, current US$) of 2008?
Your response must be concise. 5.15e+11. 